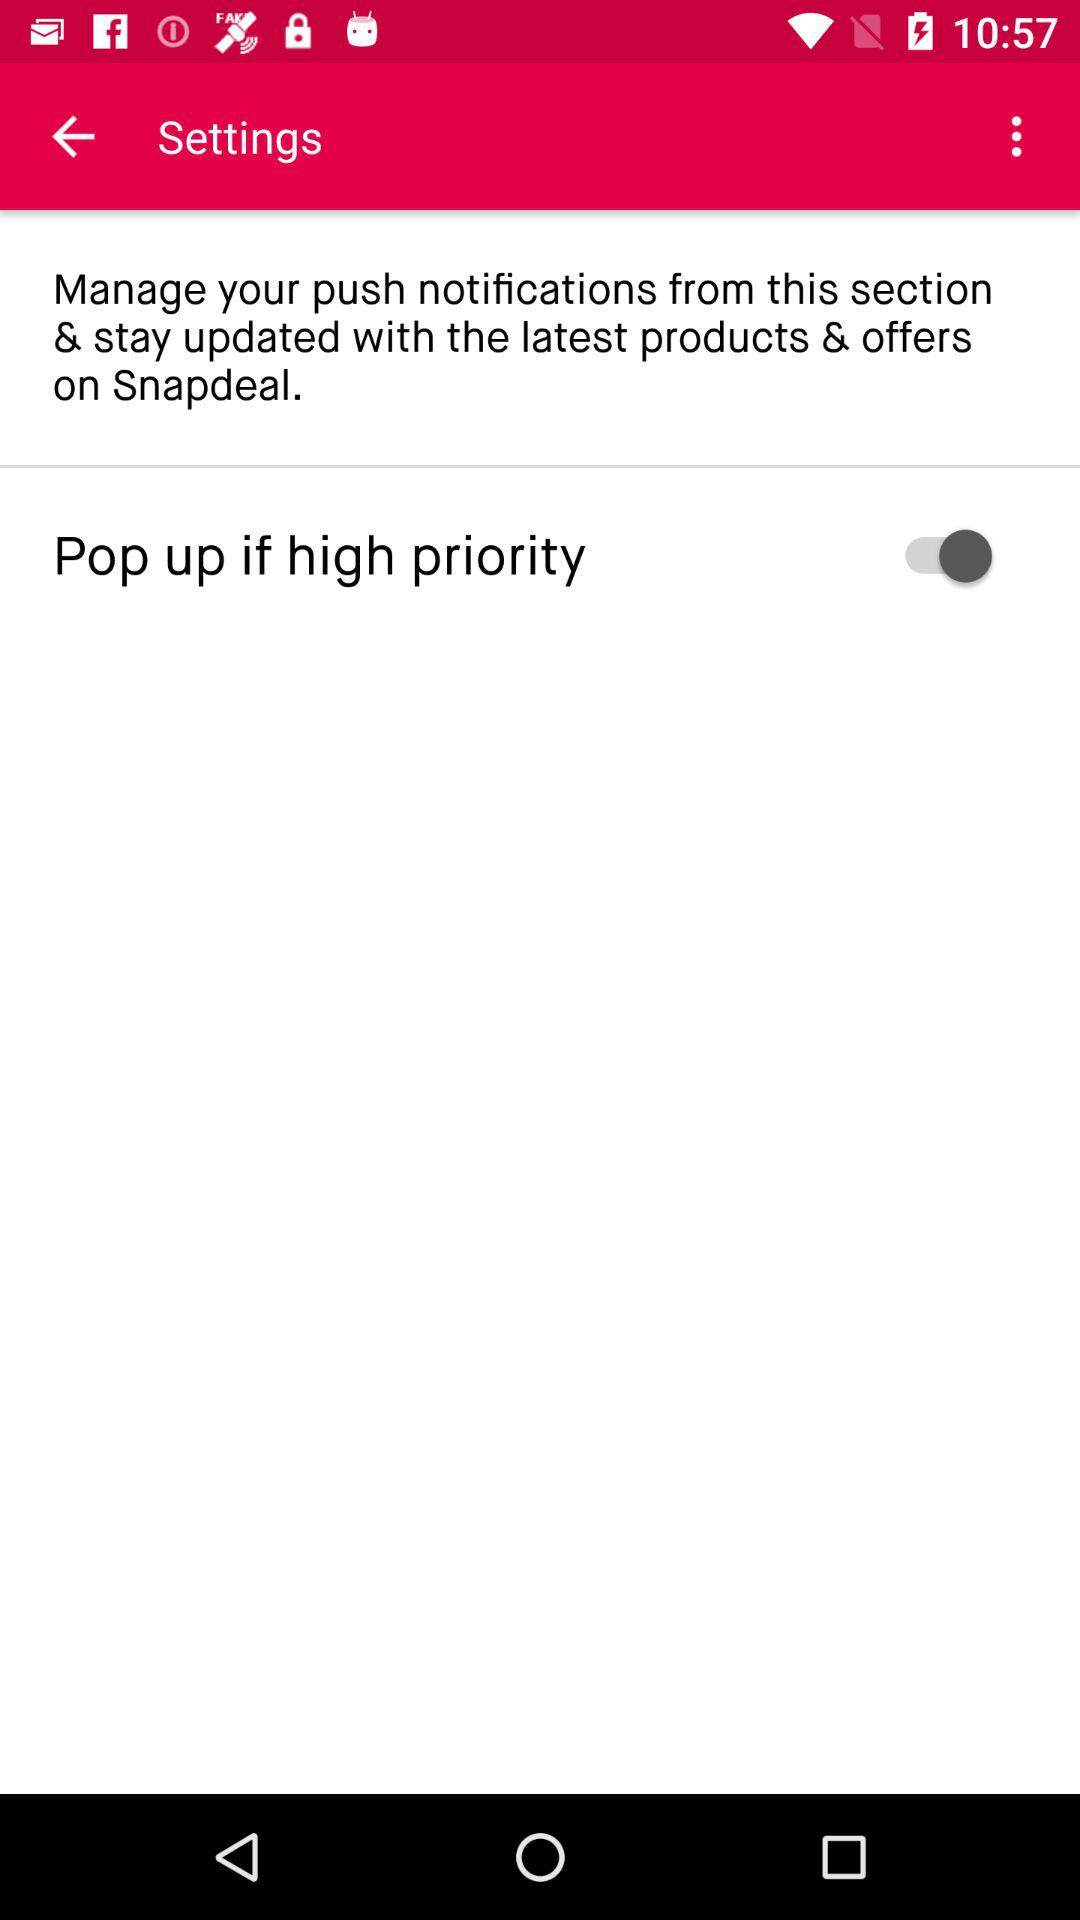What is the status of the "Pop up if high priority"? The status is "on". 